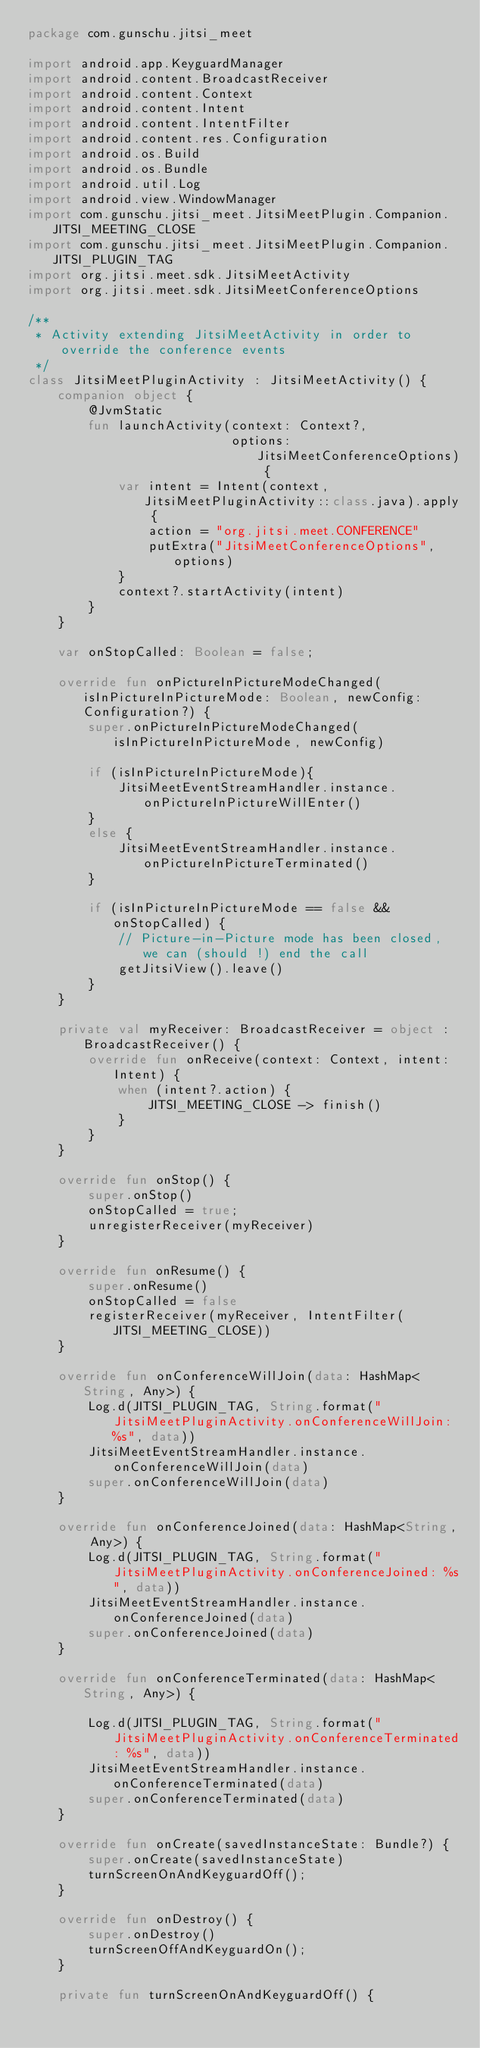<code> <loc_0><loc_0><loc_500><loc_500><_Kotlin_>package com.gunschu.jitsi_meet

import android.app.KeyguardManager
import android.content.BroadcastReceiver
import android.content.Context
import android.content.Intent
import android.content.IntentFilter
import android.content.res.Configuration
import android.os.Build
import android.os.Bundle
import android.util.Log
import android.view.WindowManager
import com.gunschu.jitsi_meet.JitsiMeetPlugin.Companion.JITSI_MEETING_CLOSE
import com.gunschu.jitsi_meet.JitsiMeetPlugin.Companion.JITSI_PLUGIN_TAG
import org.jitsi.meet.sdk.JitsiMeetActivity
import org.jitsi.meet.sdk.JitsiMeetConferenceOptions

/**
 * Activity extending JitsiMeetActivity in order to override the conference events
 */
class JitsiMeetPluginActivity : JitsiMeetActivity() {
    companion object {
        @JvmStatic
        fun launchActivity(context: Context?,
                           options: JitsiMeetConferenceOptions) {
            var intent = Intent(context, JitsiMeetPluginActivity::class.java).apply {
                action = "org.jitsi.meet.CONFERENCE"
                putExtra("JitsiMeetConferenceOptions", options)
            }
            context?.startActivity(intent)
        }
    }

    var onStopCalled: Boolean = false;

    override fun onPictureInPictureModeChanged(isInPictureInPictureMode: Boolean, newConfig: Configuration?) {
        super.onPictureInPictureModeChanged(isInPictureInPictureMode, newConfig)

        if (isInPictureInPictureMode){
            JitsiMeetEventStreamHandler.instance.onPictureInPictureWillEnter()
        }
        else {
            JitsiMeetEventStreamHandler.instance.onPictureInPictureTerminated()
        }

        if (isInPictureInPictureMode == false && onStopCalled) {
            // Picture-in-Picture mode has been closed, we can (should !) end the call
            getJitsiView().leave()
        }
    }

    private val myReceiver: BroadcastReceiver = object : BroadcastReceiver() {
        override fun onReceive(context: Context, intent: Intent) {
            when (intent?.action) {
                JITSI_MEETING_CLOSE -> finish()
            }
        }
    }

    override fun onStop() {
        super.onStop()
        onStopCalled = true;
        unregisterReceiver(myReceiver)
    }

    override fun onResume() {
        super.onResume()
        onStopCalled = false
        registerReceiver(myReceiver, IntentFilter(JITSI_MEETING_CLOSE))
    }

    override fun onConferenceWillJoin(data: HashMap<String, Any>) {
        Log.d(JITSI_PLUGIN_TAG, String.format("JitsiMeetPluginActivity.onConferenceWillJoin: %s", data))
        JitsiMeetEventStreamHandler.instance.onConferenceWillJoin(data)
        super.onConferenceWillJoin(data)
    }

    override fun onConferenceJoined(data: HashMap<String, Any>) {
        Log.d(JITSI_PLUGIN_TAG, String.format("JitsiMeetPluginActivity.onConferenceJoined: %s", data))
        JitsiMeetEventStreamHandler.instance.onConferenceJoined(data)
        super.onConferenceJoined(data)
    }

    override fun onConferenceTerminated(data: HashMap<String, Any>) {

        Log.d(JITSI_PLUGIN_TAG, String.format("JitsiMeetPluginActivity.onConferenceTerminated: %s", data))
        JitsiMeetEventStreamHandler.instance.onConferenceTerminated(data)
        super.onConferenceTerminated(data)
    }

    override fun onCreate(savedInstanceState: Bundle?) {
        super.onCreate(savedInstanceState)
        turnScreenOnAndKeyguardOff();
    }

    override fun onDestroy() {
        super.onDestroy()
        turnScreenOffAndKeyguardOn();
    }

    private fun turnScreenOnAndKeyguardOff() {</code> 